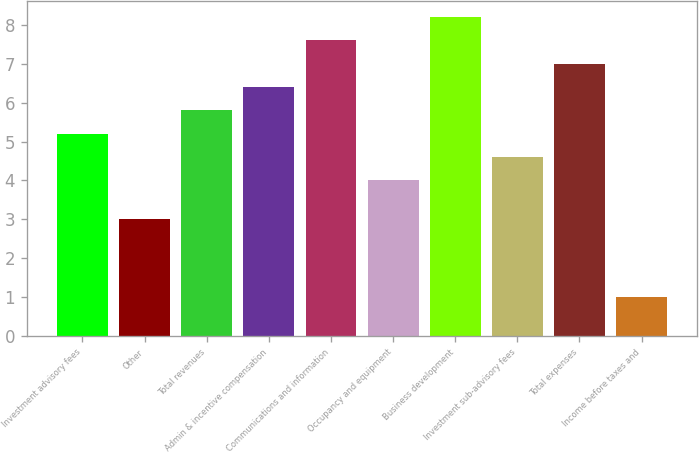Convert chart to OTSL. <chart><loc_0><loc_0><loc_500><loc_500><bar_chart><fcel>Investment advisory fees<fcel>Other<fcel>Total revenues<fcel>Admin & incentive compensation<fcel>Communications and information<fcel>Occupancy and equipment<fcel>Business development<fcel>Investment sub-advisory fees<fcel>Total expenses<fcel>Income before taxes and<nl><fcel>5.2<fcel>3<fcel>5.8<fcel>6.4<fcel>7.6<fcel>4<fcel>8.2<fcel>4.6<fcel>7<fcel>1<nl></chart> 